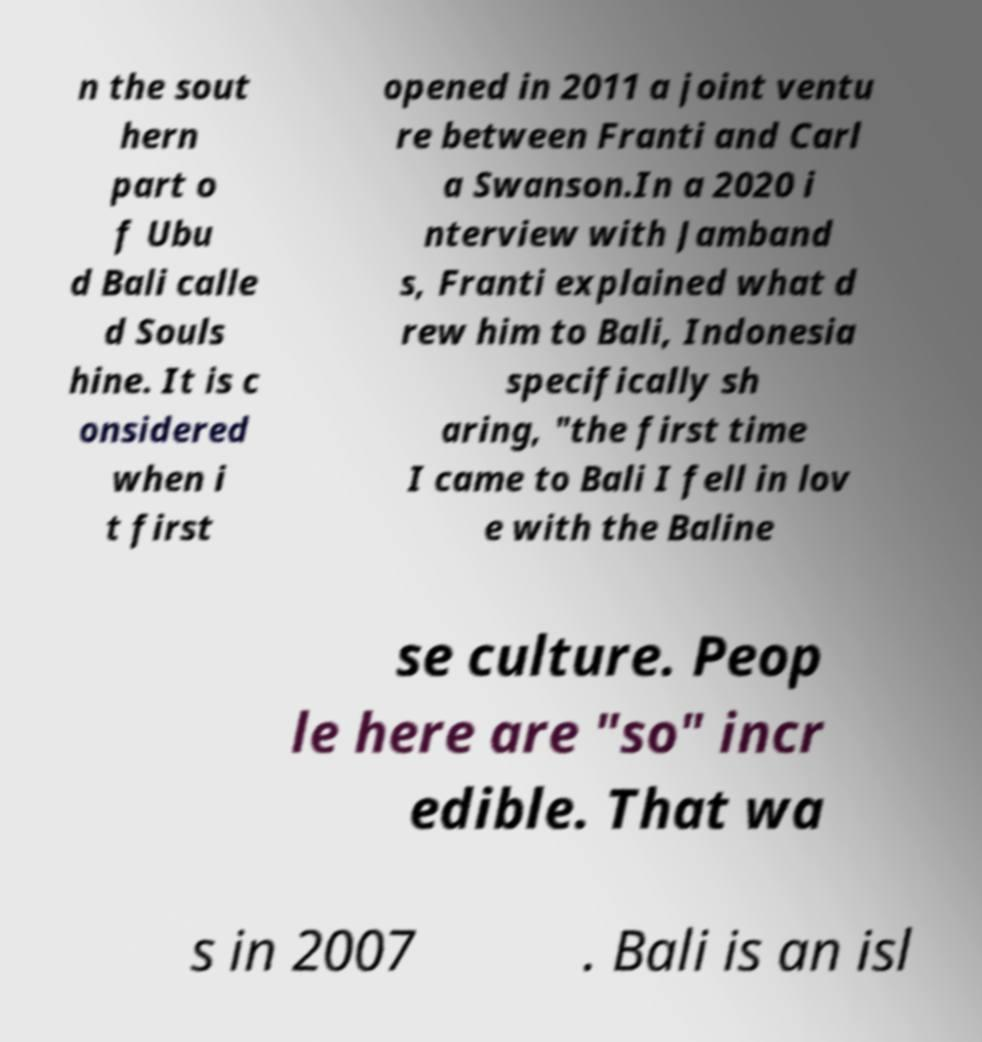Please identify and transcribe the text found in this image. n the sout hern part o f Ubu d Bali calle d Souls hine. It is c onsidered when i t first opened in 2011 a joint ventu re between Franti and Carl a Swanson.In a 2020 i nterview with Jamband s, Franti explained what d rew him to Bali, Indonesia specifically sh aring, "the first time I came to Bali I fell in lov e with the Baline se culture. Peop le here are "so" incr edible. That wa s in 2007 . Bali is an isl 